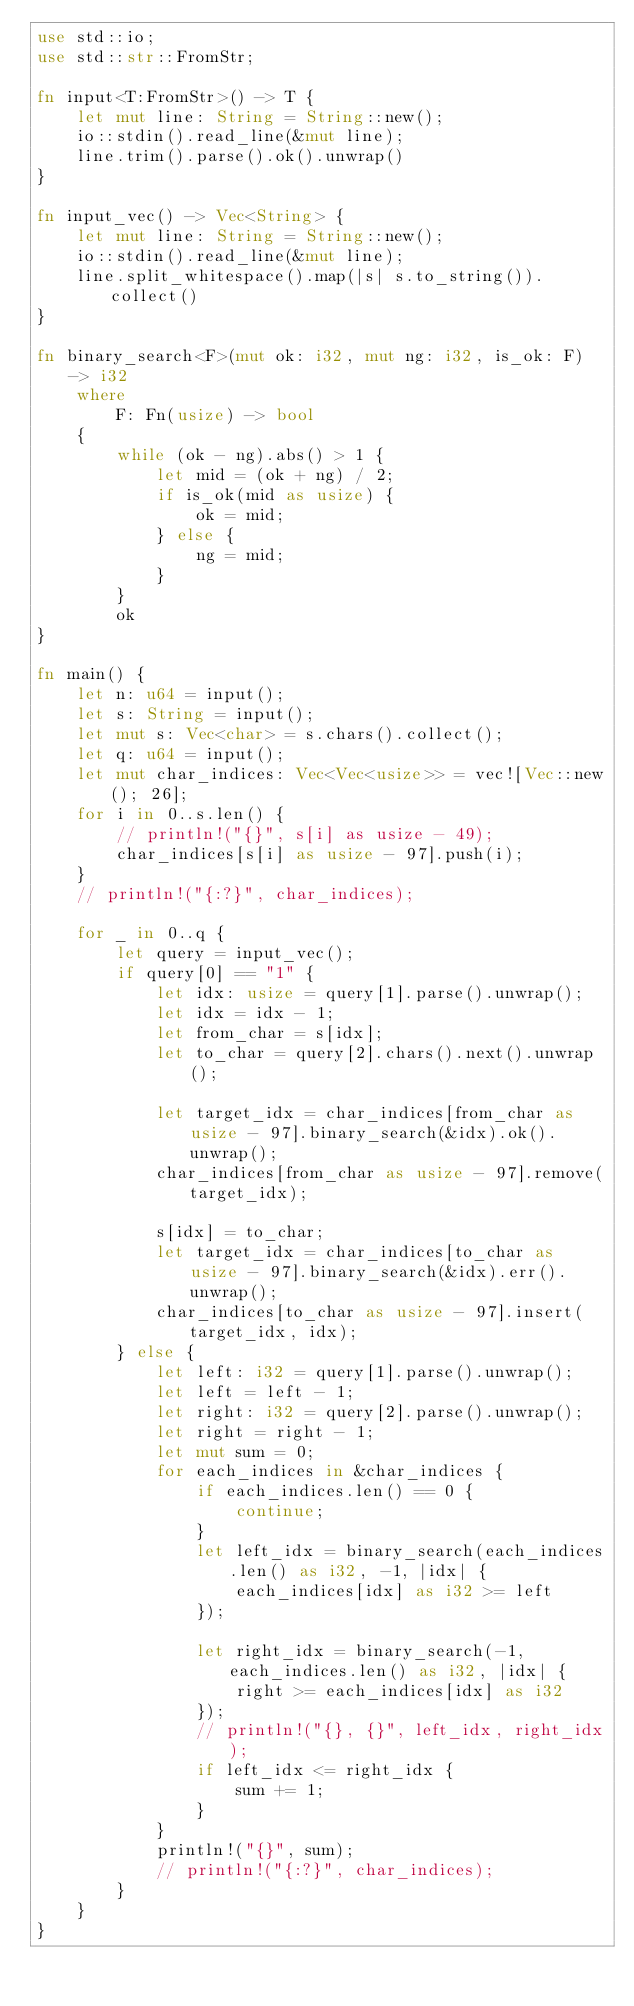Convert code to text. <code><loc_0><loc_0><loc_500><loc_500><_Rust_>use std::io;
use std::str::FromStr;

fn input<T:FromStr>() -> T {
    let mut line: String = String::new();
    io::stdin().read_line(&mut line);
    line.trim().parse().ok().unwrap()
}

fn input_vec() -> Vec<String> {
    let mut line: String = String::new();
    io::stdin().read_line(&mut line);
    line.split_whitespace().map(|s| s.to_string()).collect()
}

fn binary_search<F>(mut ok: i32, mut ng: i32, is_ok: F) -> i32
    where
        F: Fn(usize) -> bool
    {
        while (ok - ng).abs() > 1 {
            let mid = (ok + ng) / 2;
            if is_ok(mid as usize) {
                ok = mid;
            } else {
                ng = mid;
            }
        }
        ok
}

fn main() {
    let n: u64 = input();
    let s: String = input();
    let mut s: Vec<char> = s.chars().collect();
    let q: u64 = input();
    let mut char_indices: Vec<Vec<usize>> = vec![Vec::new(); 26];
    for i in 0..s.len() {
        // println!("{}", s[i] as usize - 49);
        char_indices[s[i] as usize - 97].push(i);
    }
    // println!("{:?}", char_indices);

    for _ in 0..q {
        let query = input_vec();
        if query[0] == "1" {
            let idx: usize = query[1].parse().unwrap();
            let idx = idx - 1;
            let from_char = s[idx];
            let to_char = query[2].chars().next().unwrap();

            let target_idx = char_indices[from_char as usize - 97].binary_search(&idx).ok().unwrap();
            char_indices[from_char as usize - 97].remove(target_idx);

            s[idx] = to_char;
            let target_idx = char_indices[to_char as usize - 97].binary_search(&idx).err().unwrap();
            char_indices[to_char as usize - 97].insert(target_idx, idx);
        } else {
            let left: i32 = query[1].parse().unwrap();
            let left = left - 1;
            let right: i32 = query[2].parse().unwrap();
            let right = right - 1;
            let mut sum = 0;
            for each_indices in &char_indices {
                if each_indices.len() == 0 {
                    continue;
                }
                let left_idx = binary_search(each_indices.len() as i32, -1, |idx| {
                    each_indices[idx] as i32 >= left
                });

                let right_idx = binary_search(-1, each_indices.len() as i32, |idx| {
                    right >= each_indices[idx] as i32
                });
                // println!("{}, {}", left_idx, right_idx);
                if left_idx <= right_idx {
                    sum += 1;
                }
            }
            println!("{}", sum);
            // println!("{:?}", char_indices);
        }
    }
}
</code> 